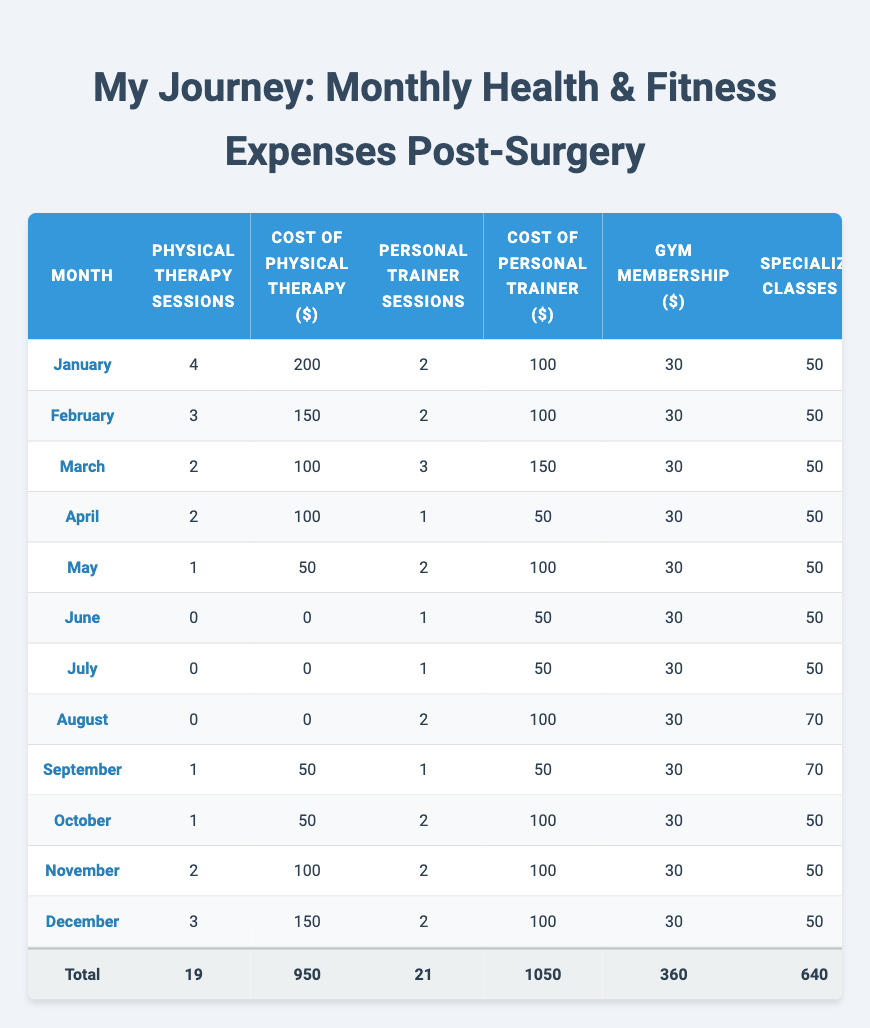What is the total cost for Nutritionist Consultations over the year? By adding the monthly costs for Nutritionist Consultations: 80 + 80 + 80 + 80 + 80 + 100 + 100 + 80 + 100 + 80 + 100 + 80 = 1040.
Answer: 1040 How many Physical Therapy Sessions were held in total throughout the year? By summing the number of Physical Therapy Sessions for each month: 4 + 3 + 2 + 2 + 1 + 0 + 0 + 0 + 1 + 1 + 2 + 3 = 19.
Answer: 19 What was the highest expense on Outdoor Equipment in a single month? Looking at the Outdoor Equipment costs month by month, the highest is $100 in March.
Answer: 100 Did the cost for Specialized Classes ever exceed $70 in any month? Review the costs for Specialized Classes: the maximum recorded is $70 in August, so it never exceeds $70.
Answer: No In which month did the total expenses peak, and what was the amount? By analyzing total expenses for each month, January has the highest total expense of $550.
Answer: January, 550 What is the average cost of Personal Trainer Sessions for the year? The costs of Personal Trainer Sessions each month are: 100, 100, 150, 50, 100, 50, 50, 100, 100, 100, 100, and 100; the sum is 1050, and dividing by the number of months (12) gives an average of 87.5.
Answer: 87.5 How does the spending on gym memberships compare in the first half versus the second half of the year? Total for the first half: January to June = 30 * 6 = 180; for the second half: July to December = 30 * 6 = 180. Thus, spending is equal in both halves.
Answer: Equal What was the cumulative cost for Physical Therapy across the months? The cumulative cost for Physical Therapy is found by adding: 200 + 150 + 100 + 100 + 50 + 0 + 0 + 0 + 50 + 50 + 100 + 150 = 950.
Answer: 950 Which month had the least total expenses, and how much were they? By reviewing the totals, the month with the least expense is July with a total of $240.
Answer: July, 240 Was there a month when the total expense was less than $300? Comparing total expenses for each month reveals that from June to August, they are all below $300. So, yes, multiple months had totals below $300.
Answer: Yes 